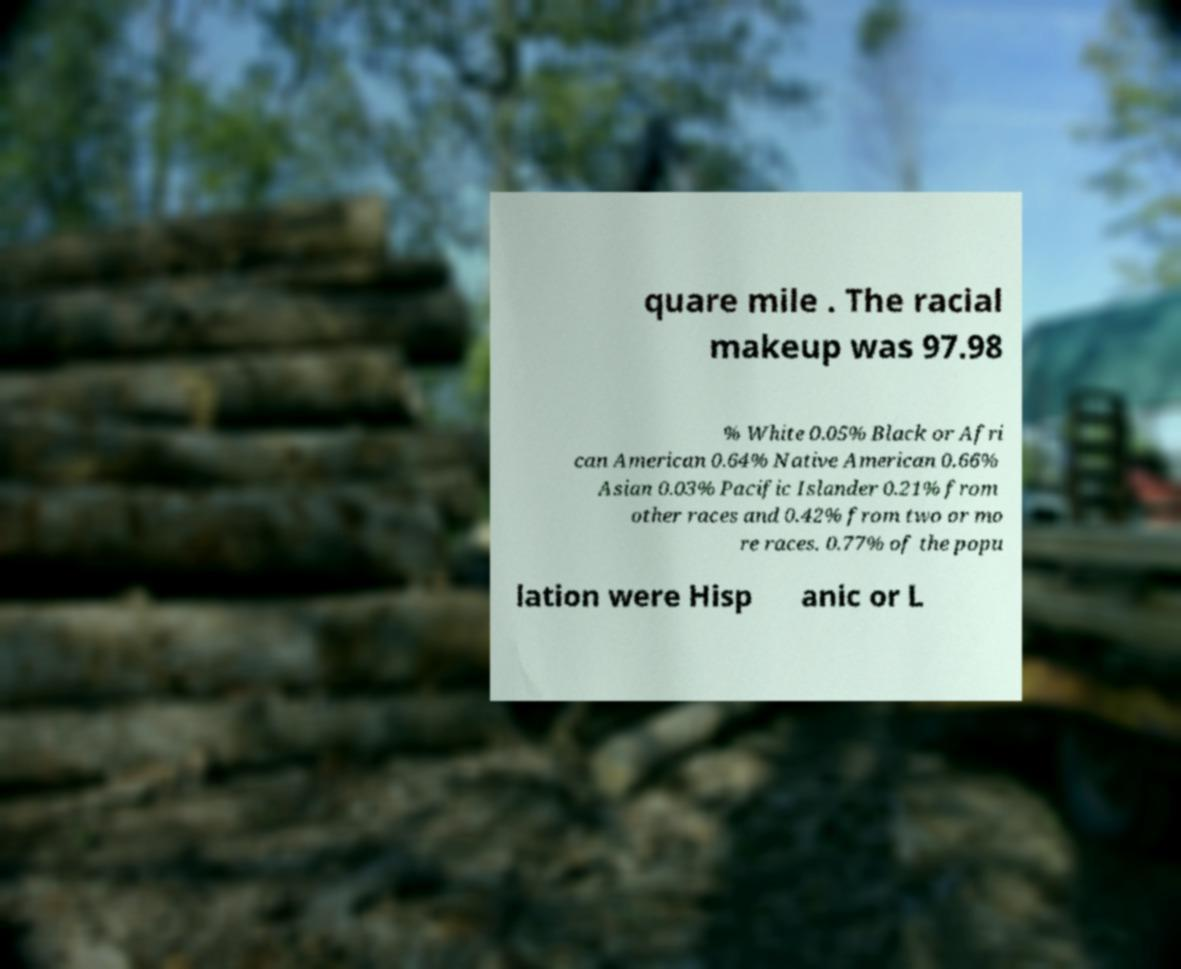Could you assist in decoding the text presented in this image and type it out clearly? quare mile . The racial makeup was 97.98 % White 0.05% Black or Afri can American 0.64% Native American 0.66% Asian 0.03% Pacific Islander 0.21% from other races and 0.42% from two or mo re races. 0.77% of the popu lation were Hisp anic or L 